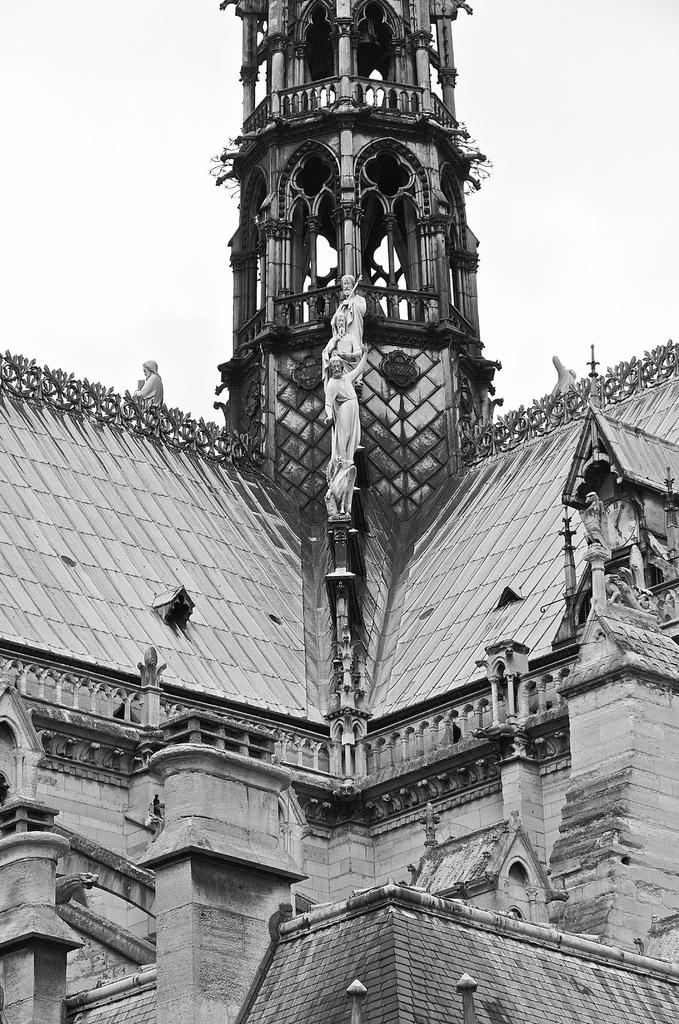What type of structure is visible in the image? There is a building in the image. What artistic elements can be seen in the image? There are sculptures in the image. How would you describe the color scheme of the image? The image is black and white in color. How many tables are present in the image? There is no table visible in the image. What sound does the whistle make in the image? There is no whistle present in the image. 